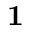<formula> <loc_0><loc_0><loc_500><loc_500>1</formula> 